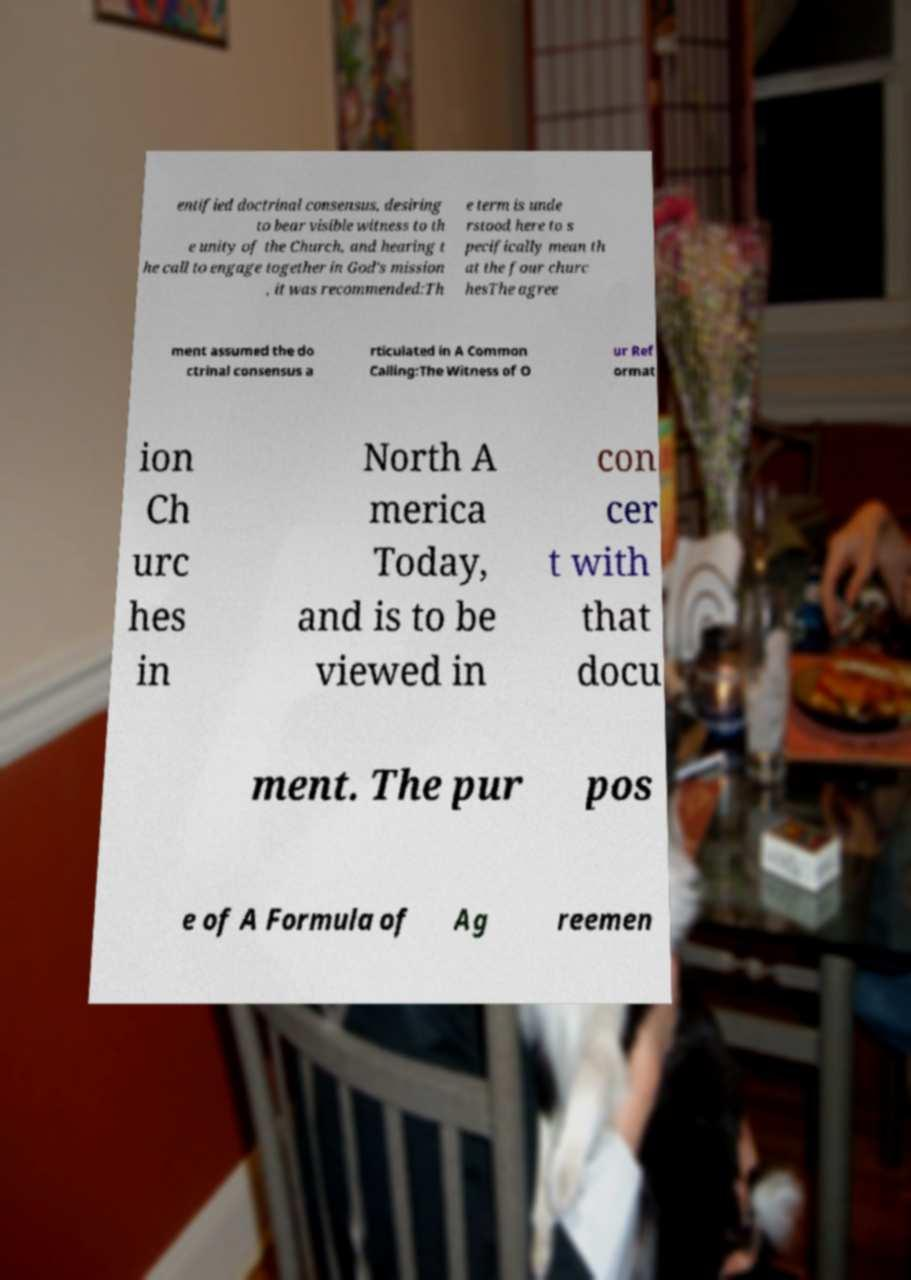Can you accurately transcribe the text from the provided image for me? entified doctrinal consensus, desiring to bear visible witness to th e unity of the Church, and hearing t he call to engage together in God's mission , it was recommended:Th e term is unde rstood here to s pecifically mean th at the four churc hesThe agree ment assumed the do ctrinal consensus a rticulated in A Common Calling:The Witness of O ur Ref ormat ion Ch urc hes in North A merica Today, and is to be viewed in con cer t with that docu ment. The pur pos e of A Formula of Ag reemen 